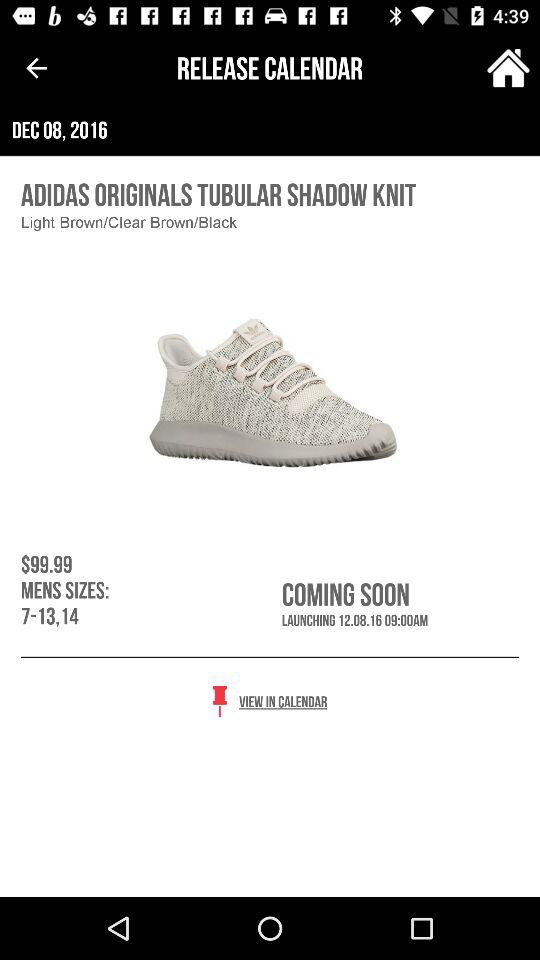What colours of shoes are available? The available colours are "Light Brown/Clear Brown/Black". 